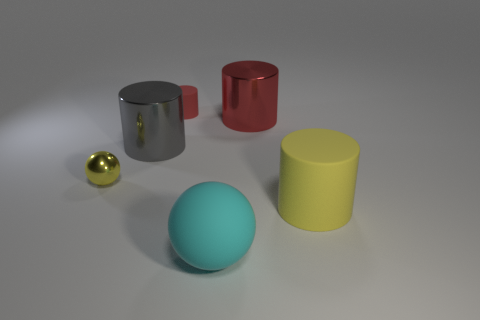Add 3 large green shiny spheres. How many objects exist? 9 Subtract all balls. How many objects are left? 4 Subtract 0 blue cubes. How many objects are left? 6 Subtract all matte things. Subtract all rubber cylinders. How many objects are left? 1 Add 6 tiny red matte cylinders. How many tiny red matte cylinders are left? 7 Add 1 big shiny cylinders. How many big shiny cylinders exist? 3 